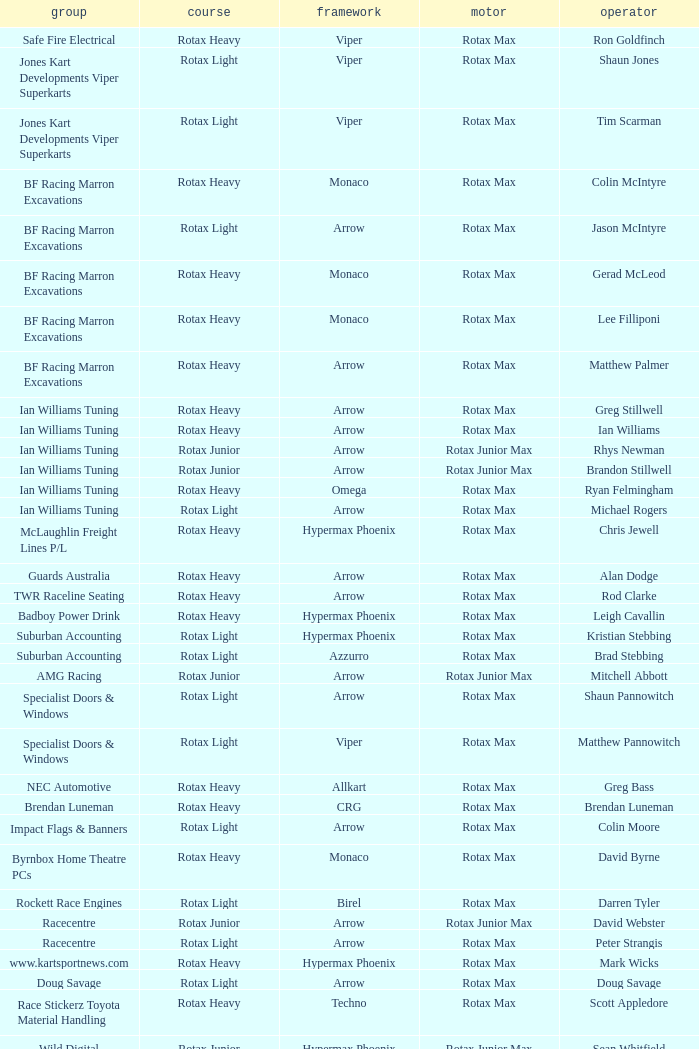What is the name of the team whose class is Rotax Light? Jones Kart Developments Viper Superkarts, Jones Kart Developments Viper Superkarts, BF Racing Marron Excavations, Ian Williams Tuning, Suburban Accounting, Suburban Accounting, Specialist Doors & Windows, Specialist Doors & Windows, Impact Flags & Banners, Rockett Race Engines, Racecentre, Doug Savage. Parse the table in full. {'header': ['group', 'course', 'framework', 'motor', 'operator'], 'rows': [['Safe Fire Electrical', 'Rotax Heavy', 'Viper', 'Rotax Max', 'Ron Goldfinch'], ['Jones Kart Developments Viper Superkarts', 'Rotax Light', 'Viper', 'Rotax Max', 'Shaun Jones'], ['Jones Kart Developments Viper Superkarts', 'Rotax Light', 'Viper', 'Rotax Max', 'Tim Scarman'], ['BF Racing Marron Excavations', 'Rotax Heavy', 'Monaco', 'Rotax Max', 'Colin McIntyre'], ['BF Racing Marron Excavations', 'Rotax Light', 'Arrow', 'Rotax Max', 'Jason McIntyre'], ['BF Racing Marron Excavations', 'Rotax Heavy', 'Monaco', 'Rotax Max', 'Gerad McLeod'], ['BF Racing Marron Excavations', 'Rotax Heavy', 'Monaco', 'Rotax Max', 'Lee Filliponi'], ['BF Racing Marron Excavations', 'Rotax Heavy', 'Arrow', 'Rotax Max', 'Matthew Palmer'], ['Ian Williams Tuning', 'Rotax Heavy', 'Arrow', 'Rotax Max', 'Greg Stillwell'], ['Ian Williams Tuning', 'Rotax Heavy', 'Arrow', 'Rotax Max', 'Ian Williams'], ['Ian Williams Tuning', 'Rotax Junior', 'Arrow', 'Rotax Junior Max', 'Rhys Newman'], ['Ian Williams Tuning', 'Rotax Junior', 'Arrow', 'Rotax Junior Max', 'Brandon Stillwell'], ['Ian Williams Tuning', 'Rotax Heavy', 'Omega', 'Rotax Max', 'Ryan Felmingham'], ['Ian Williams Tuning', 'Rotax Light', 'Arrow', 'Rotax Max', 'Michael Rogers'], ['McLaughlin Freight Lines P/L', 'Rotax Heavy', 'Hypermax Phoenix', 'Rotax Max', 'Chris Jewell'], ['Guards Australia', 'Rotax Heavy', 'Arrow', 'Rotax Max', 'Alan Dodge'], ['TWR Raceline Seating', 'Rotax Heavy', 'Arrow', 'Rotax Max', 'Rod Clarke'], ['Badboy Power Drink', 'Rotax Heavy', 'Hypermax Phoenix', 'Rotax Max', 'Leigh Cavallin'], ['Suburban Accounting', 'Rotax Light', 'Hypermax Phoenix', 'Rotax Max', 'Kristian Stebbing'], ['Suburban Accounting', 'Rotax Light', 'Azzurro', 'Rotax Max', 'Brad Stebbing'], ['AMG Racing', 'Rotax Junior', 'Arrow', 'Rotax Junior Max', 'Mitchell Abbott'], ['Specialist Doors & Windows', 'Rotax Light', 'Arrow', 'Rotax Max', 'Shaun Pannowitch'], ['Specialist Doors & Windows', 'Rotax Light', 'Viper', 'Rotax Max', 'Matthew Pannowitch'], ['NEC Automotive', 'Rotax Heavy', 'Allkart', 'Rotax Max', 'Greg Bass'], ['Brendan Luneman', 'Rotax Heavy', 'CRG', 'Rotax Max', 'Brendan Luneman'], ['Impact Flags & Banners', 'Rotax Light', 'Arrow', 'Rotax Max', 'Colin Moore'], ['Byrnbox Home Theatre PCs', 'Rotax Heavy', 'Monaco', 'Rotax Max', 'David Byrne'], ['Rockett Race Engines', 'Rotax Light', 'Birel', 'Rotax Max', 'Darren Tyler'], ['Racecentre', 'Rotax Junior', 'Arrow', 'Rotax Junior Max', 'David Webster'], ['Racecentre', 'Rotax Light', 'Arrow', 'Rotax Max', 'Peter Strangis'], ['www.kartsportnews.com', 'Rotax Heavy', 'Hypermax Phoenix', 'Rotax Max', 'Mark Wicks'], ['Doug Savage', 'Rotax Light', 'Arrow', 'Rotax Max', 'Doug Savage'], ['Race Stickerz Toyota Material Handling', 'Rotax Heavy', 'Techno', 'Rotax Max', 'Scott Appledore'], ['Wild Digital', 'Rotax Junior', 'Hypermax Phoenix', 'Rotax Junior Max', 'Sean Whitfield'], ['John Bartlett', 'Rotax Heavy', 'Hypermax Phoenix', 'Rotax Max', 'John Bartlett']]} 